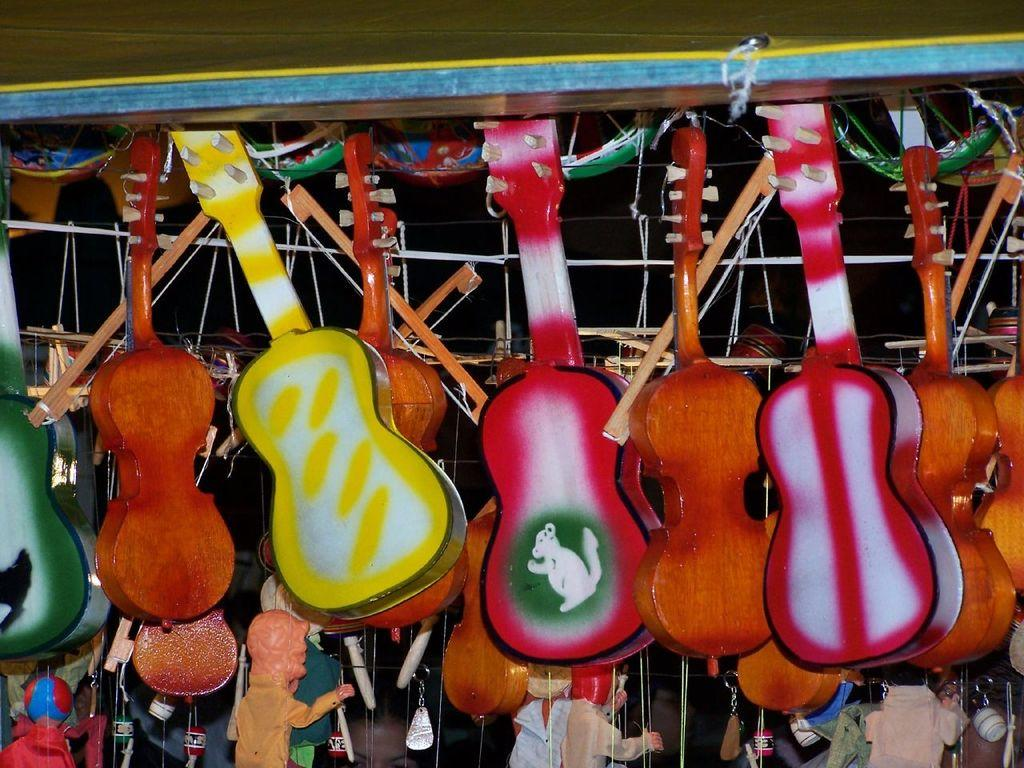What type of toys are present in the image? There are guitar toys in the image. Can you describe the appearance of the guitar toys? The guitar toys are of different colors. How are the guitar toys arranged or connected in the image? The guitar toys are tied to a rope. How many cows are present in the image? There are no cows present in the image; it features guitar toys tied to a rope. What type of business is being conducted in the image? There is no indication of a business being conducted in the image; it features guitar toys tied to a rope. 